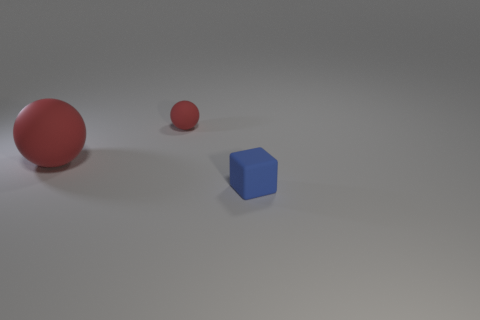Are there any other things that have the same color as the block?
Offer a very short reply. No. Is the number of small matte things that are right of the blue cube the same as the number of large red things right of the large red ball?
Provide a succinct answer. Yes. What is the size of the thing to the right of the tiny rubber object behind the cube?
Offer a very short reply. Small. What is the object that is both on the right side of the large object and to the left of the tiny block made of?
Offer a very short reply. Rubber. What number of other objects are there of the same size as the blue rubber thing?
Ensure brevity in your answer.  1. What color is the small cube?
Provide a short and direct response. Blue. There is a small matte thing to the left of the tiny matte cube; is its color the same as the matte sphere that is in front of the small red sphere?
Keep it short and to the point. Yes. There is a red thing that is left of the small sphere; what is its size?
Offer a terse response. Large. There is a rubber object that is on the left side of the tiny blue block and on the right side of the big red object; what is its shape?
Ensure brevity in your answer.  Sphere. How many other objects are there of the same shape as the tiny red object?
Give a very brief answer. 1. 